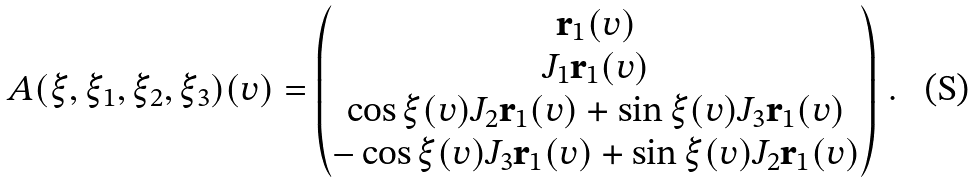Convert formula to latex. <formula><loc_0><loc_0><loc_500><loc_500>A ( \xi , \xi _ { 1 } , \xi _ { 2 } , \xi _ { 3 } ) ( v ) = \begin{pmatrix} { \mathbf r } _ { 1 } ( v ) \\ J _ { 1 } { \mathbf r } _ { 1 } ( v ) \\ \cos \xi ( v ) J _ { 2 } { \mathbf r } _ { 1 } ( v ) + \sin \xi ( v ) J _ { 3 } { \mathbf r } _ { 1 } ( v ) \\ - \cos \xi ( v ) J _ { 3 } { \mathbf r } _ { 1 } ( v ) + \sin \xi ( v ) J _ { 2 } { \mathbf r } _ { 1 } ( v ) \end{pmatrix} \, .</formula> 